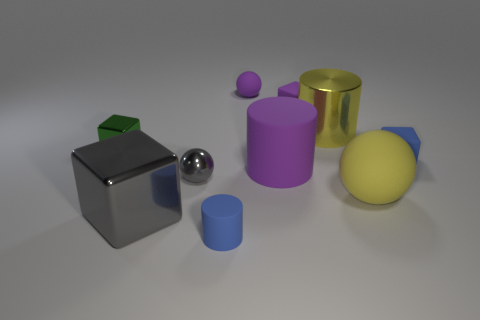What is the material of the large cylinder that is the same color as the large matte ball?
Offer a very short reply. Metal. What number of cylinders are either big cyan rubber things or tiny purple things?
Offer a terse response. 0. Do the big gray thing and the green metal object have the same shape?
Make the answer very short. Yes. What is the size of the rubber thing that is in front of the big gray object?
Ensure brevity in your answer.  Small. Is there a large metal thing that has the same color as the large sphere?
Keep it short and to the point. Yes. Is the size of the rubber block on the left side of the shiny cylinder the same as the purple sphere?
Your response must be concise. Yes. The large matte cylinder is what color?
Provide a succinct answer. Purple. The rubber sphere that is in front of the tiny blue rubber object behind the big yellow rubber thing is what color?
Keep it short and to the point. Yellow. Is there a sphere made of the same material as the large purple object?
Offer a very short reply. Yes. There is a tiny ball that is in front of the large yellow object behind the metal ball; what is it made of?
Provide a short and direct response. Metal. 